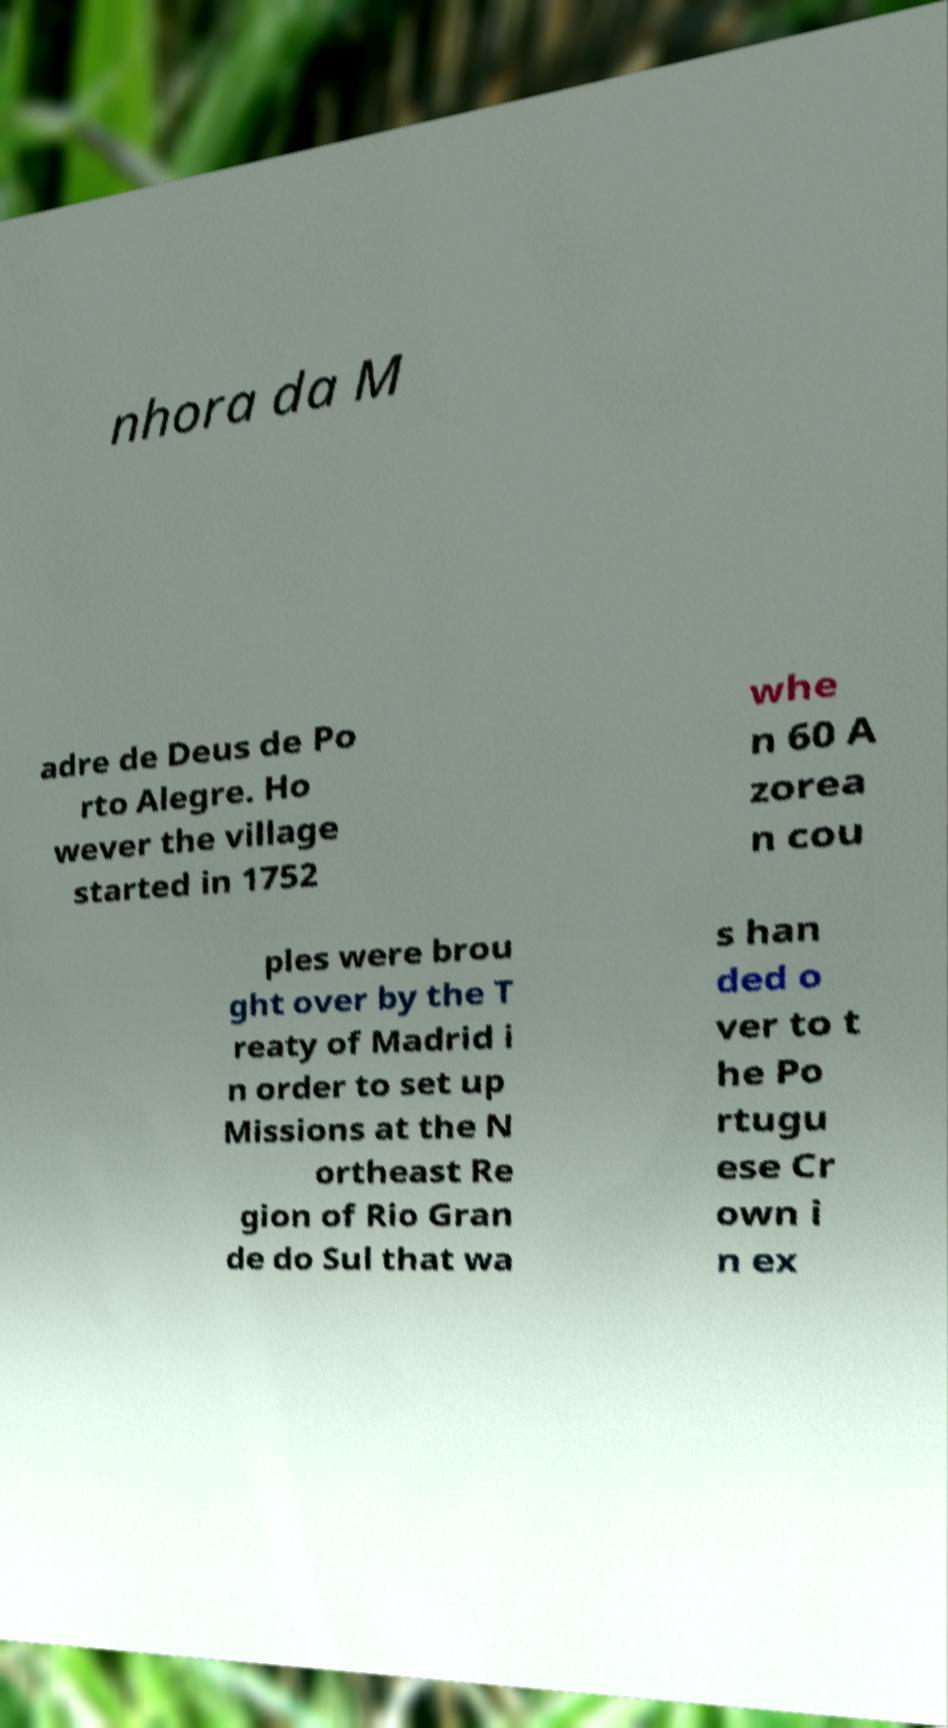What messages or text are displayed in this image? I need them in a readable, typed format. nhora da M adre de Deus de Po rto Alegre. Ho wever the village started in 1752 whe n 60 A zorea n cou ples were brou ght over by the T reaty of Madrid i n order to set up Missions at the N ortheast Re gion of Rio Gran de do Sul that wa s han ded o ver to t he Po rtugu ese Cr own i n ex 